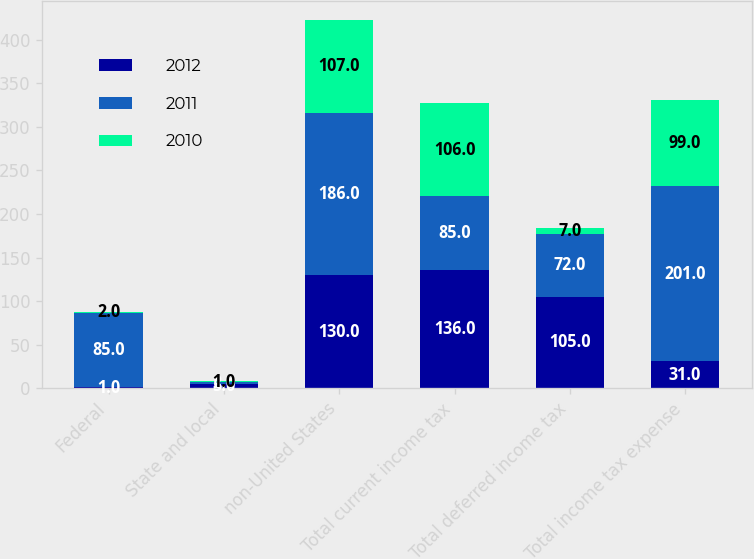<chart> <loc_0><loc_0><loc_500><loc_500><stacked_bar_chart><ecel><fcel>Federal<fcel>State and local<fcel>non-United States<fcel>Total current income tax<fcel>Total deferred income tax<fcel>Total income tax expense<nl><fcel>2012<fcel>1<fcel>5<fcel>130<fcel>136<fcel>105<fcel>31<nl><fcel>2011<fcel>85<fcel>2<fcel>186<fcel>85<fcel>72<fcel>201<nl><fcel>2010<fcel>2<fcel>1<fcel>107<fcel>106<fcel>7<fcel>99<nl></chart> 